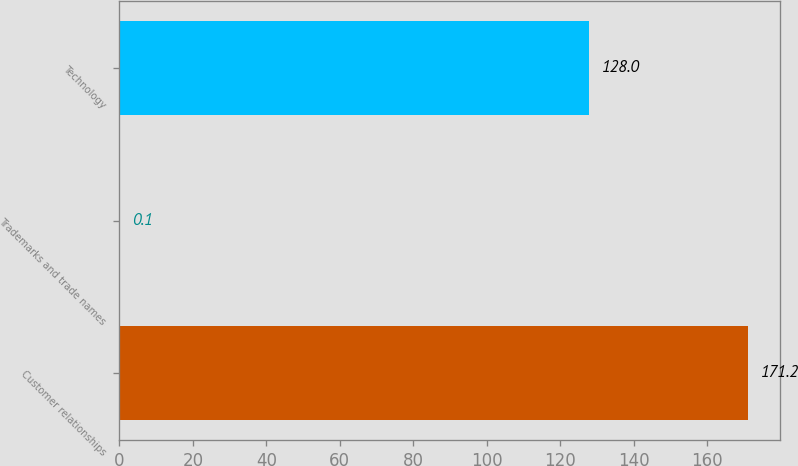Convert chart to OTSL. <chart><loc_0><loc_0><loc_500><loc_500><bar_chart><fcel>Customer relationships<fcel>Trademarks and trade names<fcel>Technology<nl><fcel>171.2<fcel>0.1<fcel>128<nl></chart> 